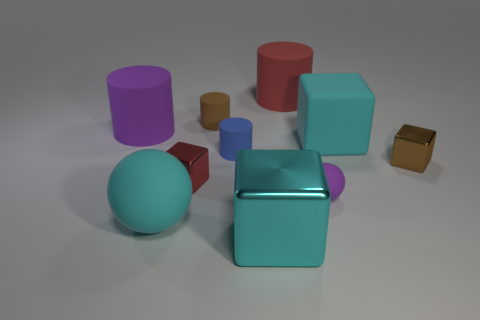Is the number of big cyan rubber things less than the number of red matte cubes?
Offer a terse response. No. How many other objects are the same color as the rubber cube?
Your response must be concise. 2. Do the sphere to the right of the small brown matte thing and the red cylinder have the same material?
Make the answer very short. Yes. There is a purple thing that is on the left side of the red metallic block; what is it made of?
Offer a very short reply. Rubber. There is a red thing in front of the large thing right of the big red rubber cylinder; how big is it?
Your answer should be very brief. Small. Is there a tiny gray thing made of the same material as the blue cylinder?
Give a very brief answer. No. What shape is the tiny metallic object that is to the left of the red thing to the right of the cyan shiny object in front of the brown block?
Provide a succinct answer. Cube. Does the tiny metal object on the right side of the purple sphere have the same color as the small matte thing in front of the tiny blue matte cylinder?
Make the answer very short. No. Is there anything else that is the same size as the blue matte cylinder?
Provide a succinct answer. Yes. Are there any small metallic things behind the tiny brown block?
Your answer should be compact. No. 